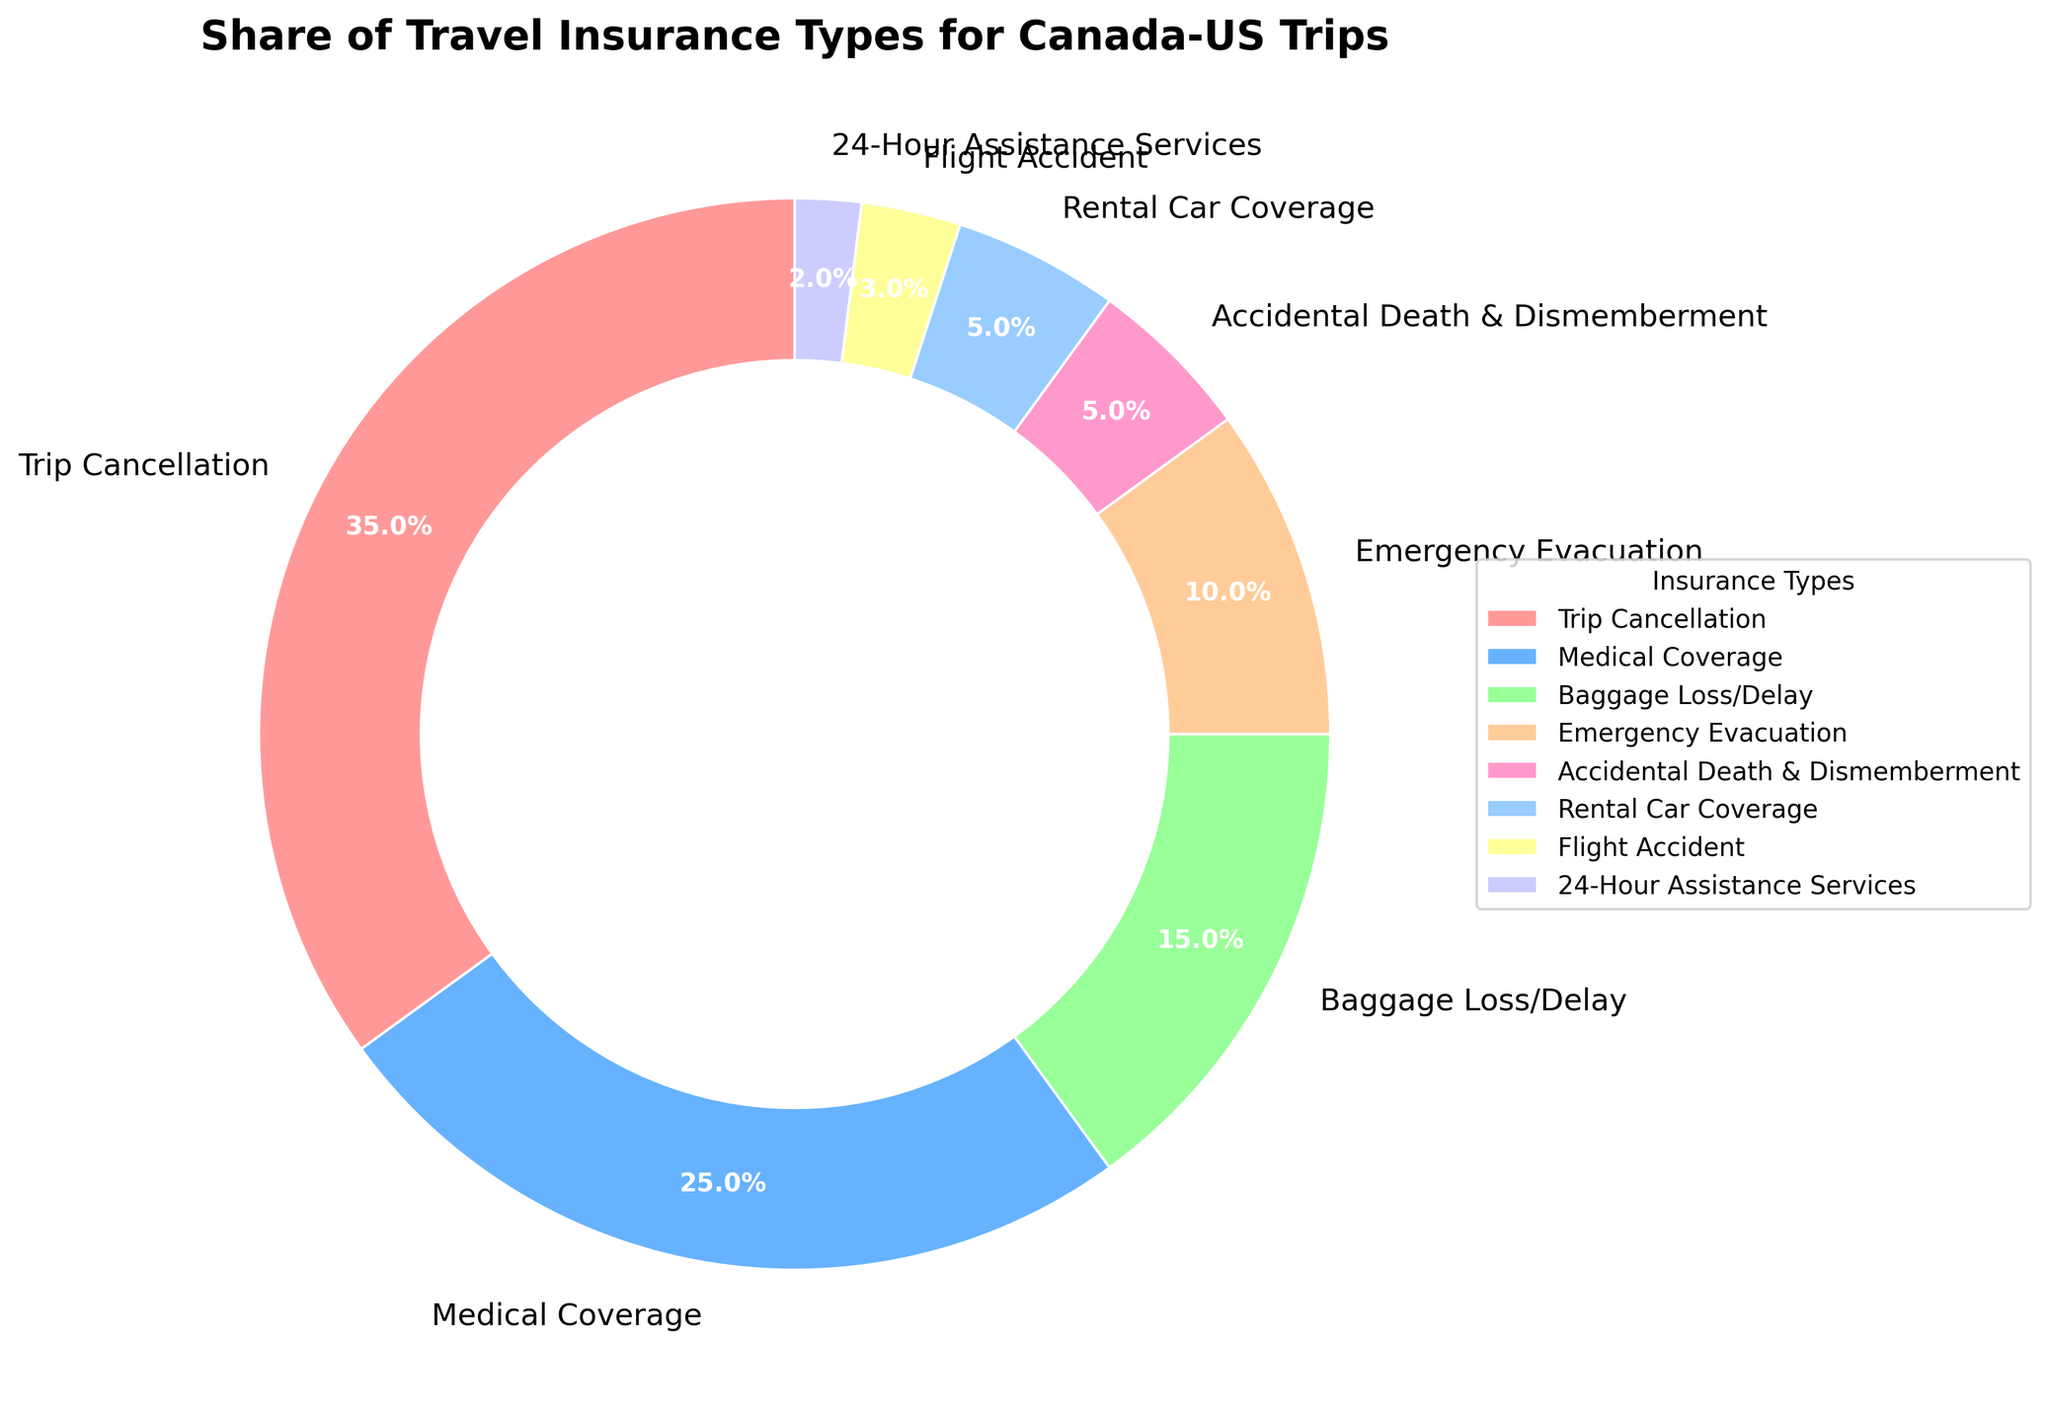What type of travel insurance has the largest share? Trip Cancellation has the largest share. By looking at the pie chart, Trip Cancellation occupies the largest segment, labeled with 35%.
Answer: Trip Cancellation How much larger is the percentage of Trip Cancellation compared to Medical Coverage? The percentage of Trip Cancellation is 35%, and the percentage of Medical Coverage is 25%. The difference is calculated by subtracting the smaller percentage from the larger one: 35% - 25% = 10%.
Answer: 10% Which insurance types have the smallest shares, and what are their percentages? The smallest shares belong to 24-Hour Assistance Services with 2% and Flight Accident with 3%. By looking at the chart, these are the smallest slices in the pie chart.
Answer: 24-Hour Assistance Services (2%), Flight Accident (3%) What is the total percentage of insurance types related to accidents (Flight Accident, Accidental Death & Dismemberment)? The percentage of Flight Accident insurance is 3% and Accidental Death & Dismemberment is 5%. Adding these together gives a total of 3% + 5% = 8%.
Answer: 8% What is the combined percentage of all insurance types excluding Trip Cancellation and Medical Coverage? Excluding Trip Cancellation (35%) and Medical Coverage (25%), we sum up the remaining percentages: 15% (Baggage Loss/Delay) + 10% (Emergency Evacuation) + 5% (Accidental Death & Dismemberment) + 5% (Rental Car Coverage) + 3% (Flight Accident) + 2% (24-Hour Assistance Services) = 40%.
Answer: 40% What is the second most purchased type of travel insurance? The second most purchased type of travel insurance is Medical Coverage, occupying the second largest segment at 25%.
Answer: Medical Coverage How does the share of Baggage Loss/Delay compare to the share of Rental Car Coverage? The share of Baggage Loss/Delay is 15%, while the share of Rental Car Coverage is 5%. Baggage Loss/Delay is 10% larger than Rental Car Coverage.
Answer: 10% What types of insurance have more than 10% but less than 30% share? Medical Coverage and Baggage Loss/Delay fall within this range. Medical Coverage is 25% and Baggage Loss/Delay is 15%, both fitting the criteria.
Answer: Medical Coverage, Baggage Loss/Delay 